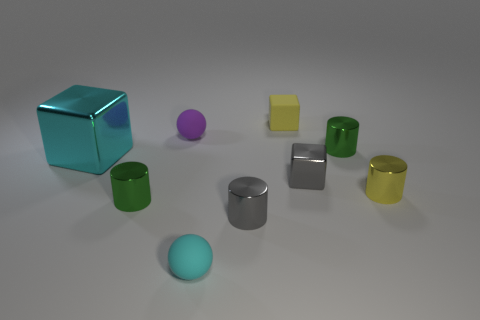What shape is the tiny yellow matte thing?
Ensure brevity in your answer.  Cube. There is a metallic cube on the right side of the cyan thing in front of the gray cylinder; what number of rubber things are behind it?
Keep it short and to the point. 2. How many other objects are the same material as the big block?
Make the answer very short. 5. There is a cyan ball that is the same size as the yellow cube; what material is it?
Provide a succinct answer. Rubber. Do the rubber sphere that is on the right side of the purple rubber sphere and the tiny rubber sphere that is behind the tiny gray block have the same color?
Your answer should be very brief. No. Are there any tiny red metal things that have the same shape as the purple rubber object?
Offer a very short reply. No. There is a cyan matte thing that is the same size as the yellow rubber block; what is its shape?
Make the answer very short. Sphere. What number of tiny spheres are the same color as the big metallic object?
Give a very brief answer. 1. What is the size of the green shiny object right of the cyan matte ball?
Ensure brevity in your answer.  Small. How many purple objects are the same size as the yellow block?
Your answer should be very brief. 1. 